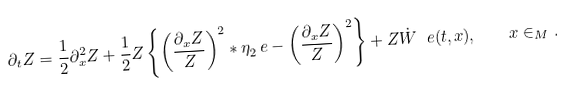<formula> <loc_0><loc_0><loc_500><loc_500>\partial _ { t } Z = \frac { 1 } { 2 } \partial _ { x } ^ { 2 } Z + \frac { 1 } { 2 } Z \left \{ \left ( \frac { \partial _ { x } Z } Z \right ) ^ { 2 } * \eta _ { 2 } ^ { \ } e - \left ( \frac { \partial _ { x } Z } Z \right ) ^ { 2 } \right \} + Z \dot { W } ^ { \ } e ( t , x ) , \quad x \in _ { M } .</formula> 